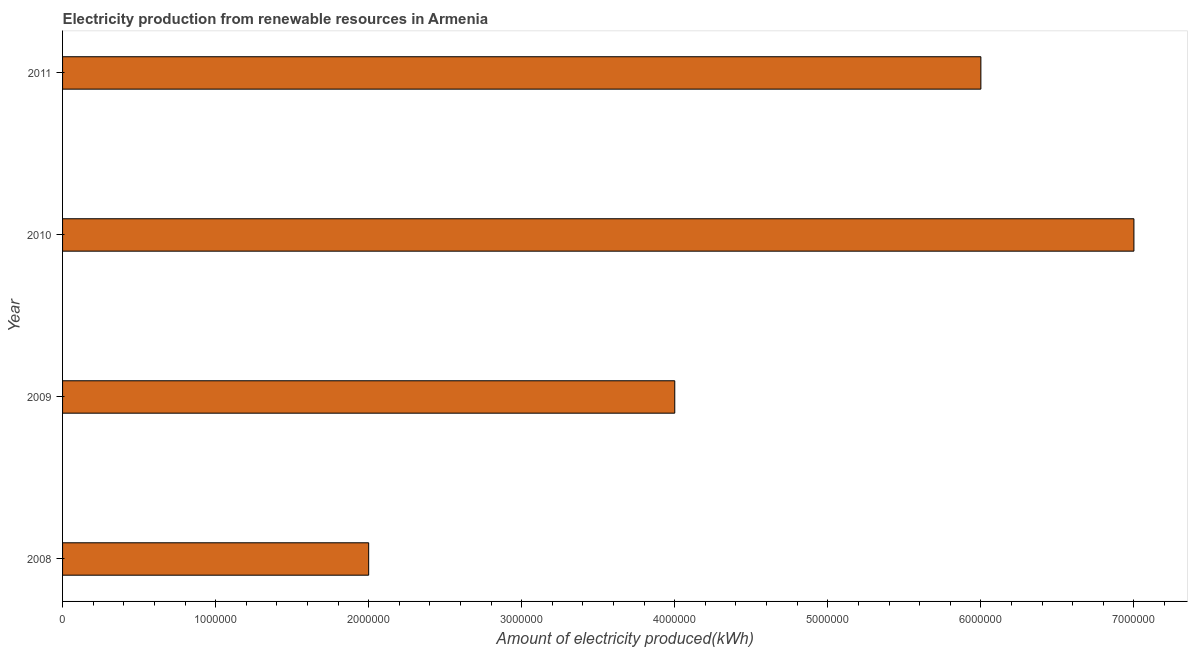What is the title of the graph?
Give a very brief answer. Electricity production from renewable resources in Armenia. What is the label or title of the X-axis?
Offer a very short reply. Amount of electricity produced(kWh). Across all years, what is the minimum amount of electricity produced?
Offer a very short reply. 2.00e+06. In which year was the amount of electricity produced maximum?
Your response must be concise. 2010. In which year was the amount of electricity produced minimum?
Offer a very short reply. 2008. What is the sum of the amount of electricity produced?
Your answer should be very brief. 1.90e+07. What is the difference between the amount of electricity produced in 2008 and 2010?
Ensure brevity in your answer.  -5.00e+06. What is the average amount of electricity produced per year?
Ensure brevity in your answer.  4.75e+06. In how many years, is the amount of electricity produced greater than 1800000 kWh?
Offer a terse response. 4. What is the ratio of the amount of electricity produced in 2009 to that in 2011?
Your response must be concise. 0.67. Is the amount of electricity produced in 2010 less than that in 2011?
Keep it short and to the point. No. Is the sum of the amount of electricity produced in 2008 and 2009 greater than the maximum amount of electricity produced across all years?
Make the answer very short. No. What is the difference between the highest and the lowest amount of electricity produced?
Provide a succinct answer. 5.00e+06. In how many years, is the amount of electricity produced greater than the average amount of electricity produced taken over all years?
Your answer should be very brief. 2. Are all the bars in the graph horizontal?
Provide a short and direct response. Yes. What is the Amount of electricity produced(kWh) of 2008?
Offer a terse response. 2.00e+06. What is the Amount of electricity produced(kWh) of 2009?
Your answer should be compact. 4.00e+06. What is the Amount of electricity produced(kWh) in 2011?
Your response must be concise. 6.00e+06. What is the difference between the Amount of electricity produced(kWh) in 2008 and 2010?
Ensure brevity in your answer.  -5.00e+06. What is the difference between the Amount of electricity produced(kWh) in 2008 and 2011?
Keep it short and to the point. -4.00e+06. What is the ratio of the Amount of electricity produced(kWh) in 2008 to that in 2009?
Give a very brief answer. 0.5. What is the ratio of the Amount of electricity produced(kWh) in 2008 to that in 2010?
Offer a very short reply. 0.29. What is the ratio of the Amount of electricity produced(kWh) in 2008 to that in 2011?
Your response must be concise. 0.33. What is the ratio of the Amount of electricity produced(kWh) in 2009 to that in 2010?
Provide a succinct answer. 0.57. What is the ratio of the Amount of electricity produced(kWh) in 2009 to that in 2011?
Your answer should be compact. 0.67. What is the ratio of the Amount of electricity produced(kWh) in 2010 to that in 2011?
Keep it short and to the point. 1.17. 